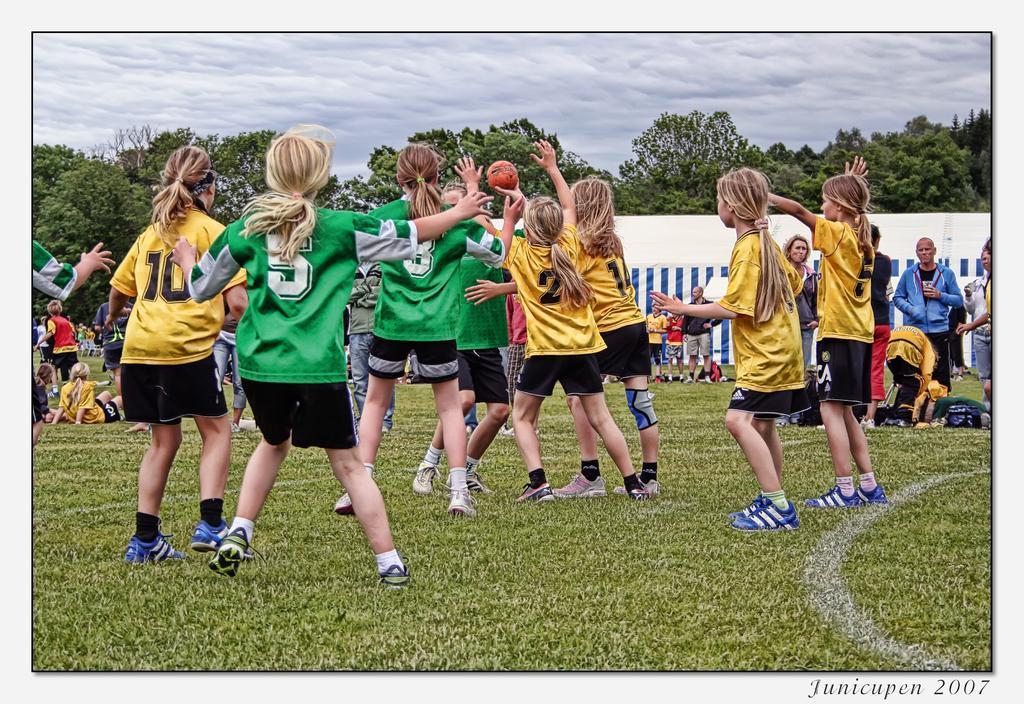Describe this image in one or two sentences. In this image we can see an edited image. In this image we can see some people, ball and other objects. In the background of the image there are some people, trees, wall and other objects. At the top of the image there is the sky. At the bottom of the image there is the grass. On the image there is a watermark. 